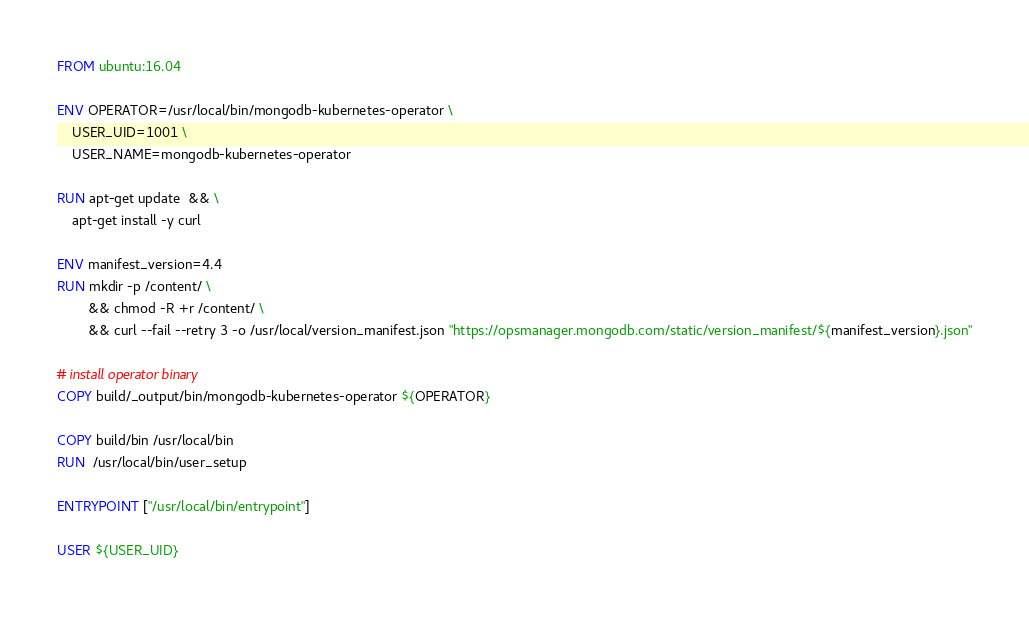Convert code to text. <code><loc_0><loc_0><loc_500><loc_500><_Dockerfile_>FROM ubuntu:16.04

ENV OPERATOR=/usr/local/bin/mongodb-kubernetes-operator \
    USER_UID=1001 \
    USER_NAME=mongodb-kubernetes-operator

RUN apt-get update  && \
    apt-get install -y curl

ENV manifest_version=4.4
RUN mkdir -p /content/ \
        && chmod -R +r /content/ \
        && curl --fail --retry 3 -o /usr/local/version_manifest.json "https://opsmanager.mongodb.com/static/version_manifest/${manifest_version}.json"

# install operator binary
COPY build/_output/bin/mongodb-kubernetes-operator ${OPERATOR}

COPY build/bin /usr/local/bin
RUN  /usr/local/bin/user_setup

ENTRYPOINT ["/usr/local/bin/entrypoint"]

USER ${USER_UID}
</code> 